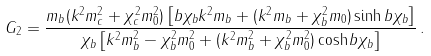Convert formula to latex. <formula><loc_0><loc_0><loc_500><loc_500>G _ { 2 } = \frac { m _ { b } ( k ^ { 2 } m _ { c } ^ { 2 } + \chi _ { c } ^ { 2 } m _ { 0 } ^ { 2 } ) \left [ b \chi _ { b } k ^ { 2 } m _ { b } + ( k ^ { 2 } m _ { b } + \chi _ { b } ^ { 2 } m _ { 0 } ) \sinh b \chi _ { b } \right ] } { \chi _ { b } \left [ k ^ { 2 } m _ { b } ^ { 2 } - \chi _ { b } ^ { 2 } m _ { 0 } ^ { 2 } + ( k ^ { 2 } m _ { b } ^ { 2 } + \chi _ { b } ^ { 2 } m _ { 0 } ^ { 2 } ) \cosh b \chi _ { b } \right ] } \, .</formula> 